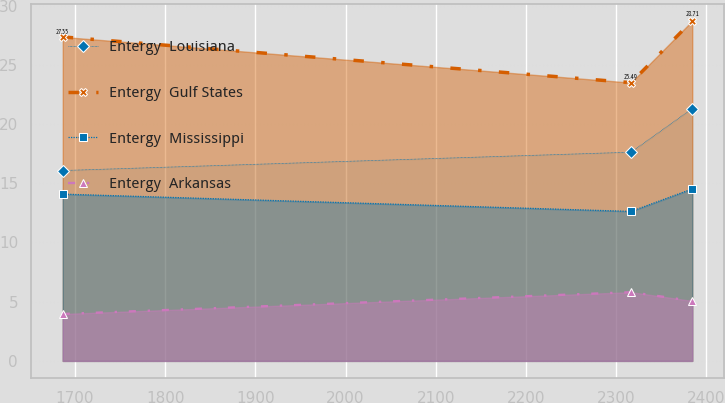Convert chart to OTSL. <chart><loc_0><loc_0><loc_500><loc_500><line_chart><ecel><fcel>Entergy  Louisiana<fcel>Entergy  Gulf States<fcel>Entergy  Mississippi<fcel>Entergy  Arkansas<nl><fcel>1686.38<fcel>16.07<fcel>27.35<fcel>14.08<fcel>3.96<nl><fcel>2316.59<fcel>17.62<fcel>23.49<fcel>12.62<fcel>5.8<nl><fcel>2384.4<fcel>21.3<fcel>28.71<fcel>14.52<fcel>5.06<nl></chart> 